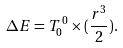Convert formula to latex. <formula><loc_0><loc_0><loc_500><loc_500>\Delta E = T _ { 0 } ^ { \, 0 } \times ( \frac { r ^ { 3 } } { 2 } ) .</formula> 